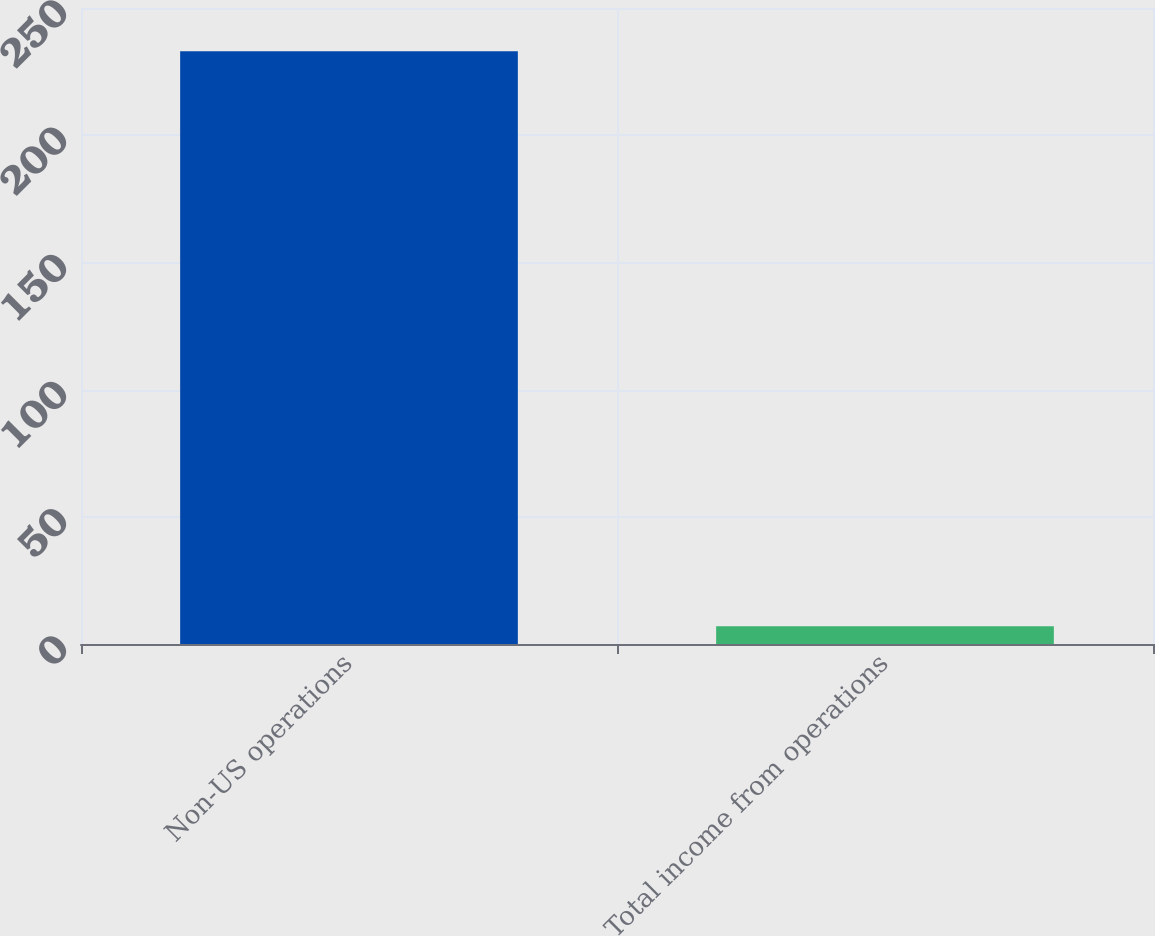<chart> <loc_0><loc_0><loc_500><loc_500><bar_chart><fcel>Non-US operations<fcel>Total income from operations<nl><fcel>233<fcel>7<nl></chart> 